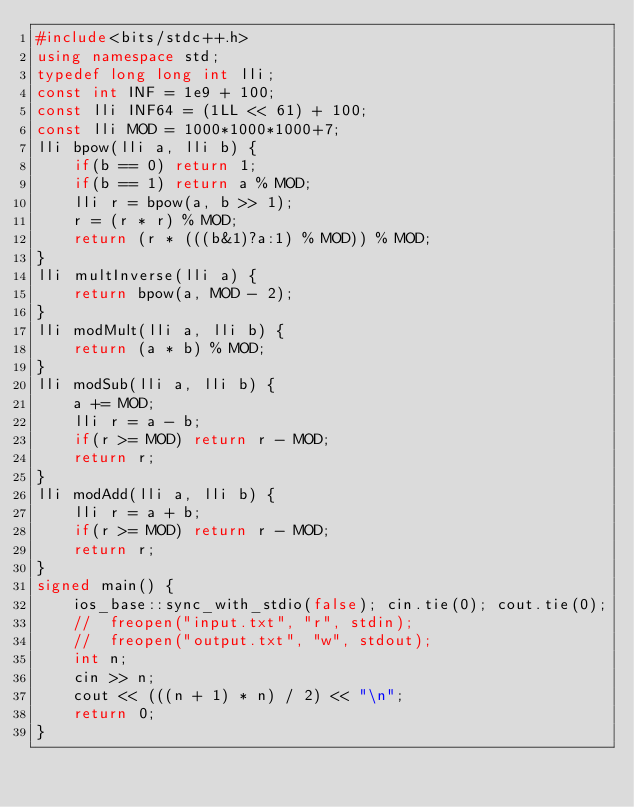Convert code to text. <code><loc_0><loc_0><loc_500><loc_500><_C++_>#include<bits/stdc++.h>
using namespace std;
typedef long long int lli;
const int INF = 1e9 + 100;
const lli INF64 = (1LL << 61) + 100;
const lli MOD = 1000*1000*1000+7;
lli bpow(lli a, lli b) {
	if(b == 0) return 1;
	if(b == 1) return a % MOD;
	lli r = bpow(a, b >> 1);
	r = (r * r) % MOD;
	return (r * (((b&1)?a:1) % MOD)) % MOD;
}
lli multInverse(lli a) {
	return bpow(a, MOD - 2);
}
lli modMult(lli a, lli b) {
	return (a * b) % MOD;
}
lli modSub(lli a, lli b) {
	a += MOD;
	lli r = a - b;
	if(r >= MOD) return r - MOD;
	return r;
}
lli modAdd(lli a, lli b) {
	lli r = a + b;
	if(r >= MOD) return r - MOD;
	return r;
}
signed main() {
	ios_base::sync_with_stdio(false); cin.tie(0); cout.tie(0);
	//	freopen("input.txt", "r", stdin);
	//	freopen("output.txt", "w", stdout);
	int n;
	cin >> n;
	cout << (((n + 1) * n) / 2) << "\n";
	return 0;
}</code> 